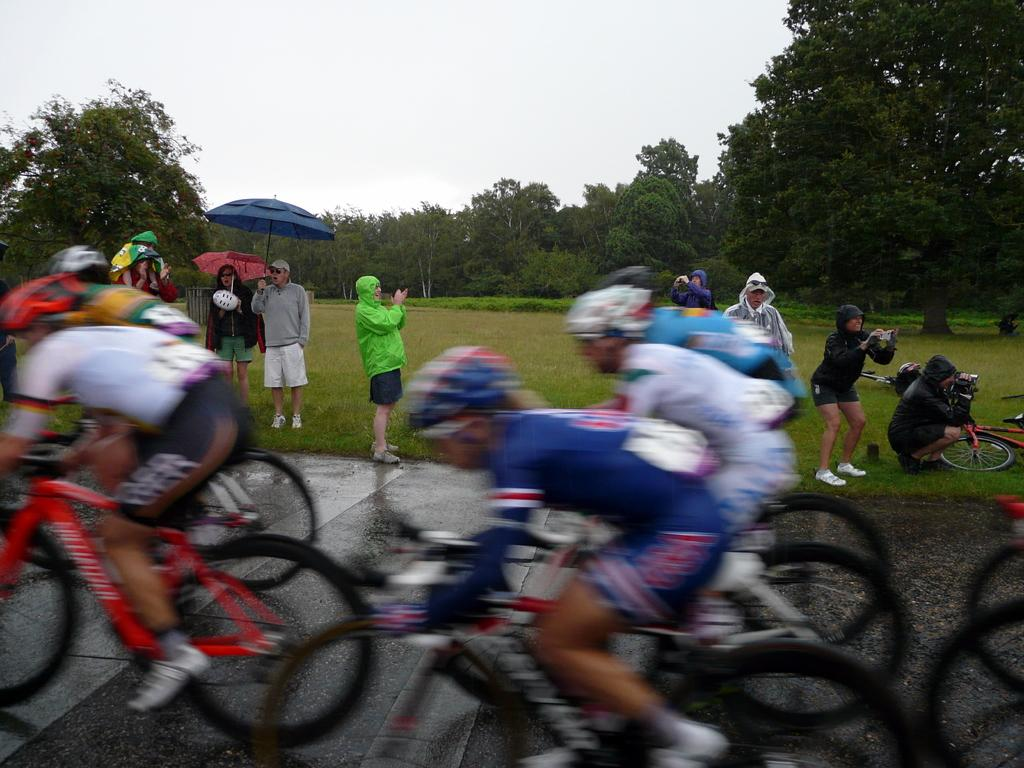What is the main feature of the image? There is a road in the image. What is happening on the road? Bicycles are moving on the road. What can be seen in the background of the image? There are people standing on grass and trees in the background. What else is visible in the image? The sky is visible in the image. What type of bun is being used to hold the bicycles together in the image? There is no bun present in the image, and the bicycles are not being held together. 